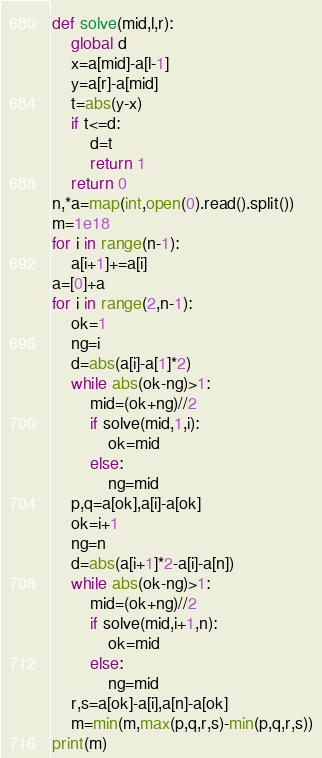Convert code to text. <code><loc_0><loc_0><loc_500><loc_500><_Python_>def solve(mid,l,r):
    global d
    x=a[mid]-a[l-1]
    y=a[r]-a[mid]
    t=abs(y-x)
    if t<=d:
        d=t
        return 1
    return 0
n,*a=map(int,open(0).read().split())
m=1e18
for i in range(n-1):
    a[i+1]+=a[i]
a=[0]+a
for i in range(2,n-1):
    ok=1
    ng=i
    d=abs(a[i]-a[1]*2)
    while abs(ok-ng)>1:
        mid=(ok+ng)//2
        if solve(mid,1,i):
            ok=mid
        else:
            ng=mid
    p,q=a[ok],a[i]-a[ok]
    ok=i+1
    ng=n
    d=abs(a[i+1]*2-a[i]-a[n])
    while abs(ok-ng)>1:
        mid=(ok+ng)//2
        if solve(mid,i+1,n):
            ok=mid
        else:
            ng=mid
    r,s=a[ok]-a[i],a[n]-a[ok]
    m=min(m,max(p,q,r,s)-min(p,q,r,s))
print(m)</code> 